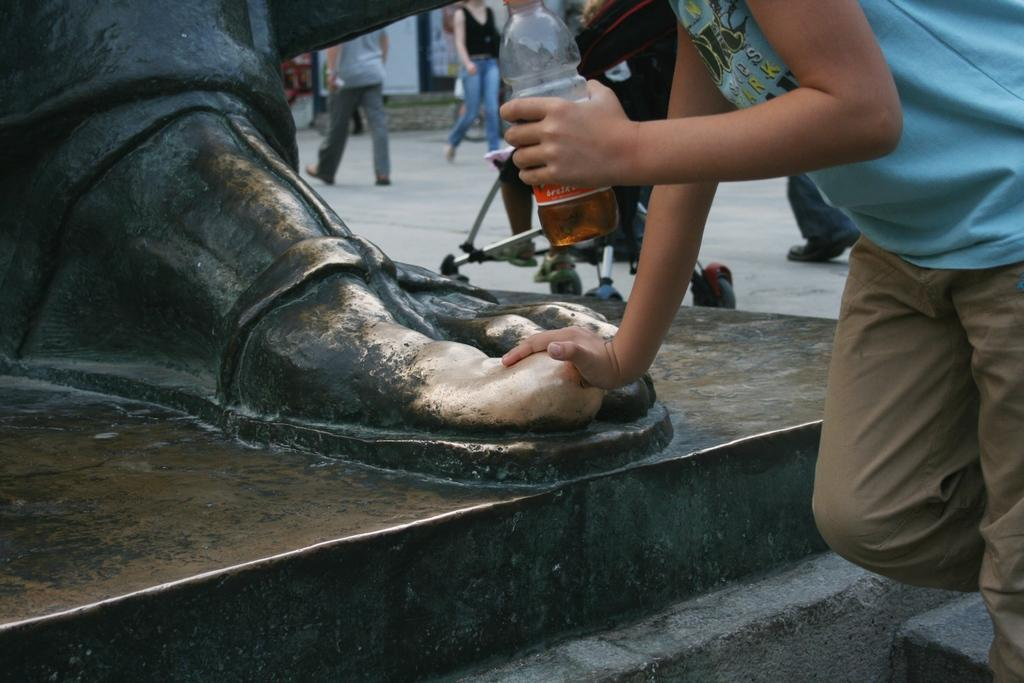What is the main subject of the image? There is a sculpture in the image. Are there any other elements in the image besides the sculpture? Yes, there is a group of people in the image. Can you describe the time of day when the image was taken? The image appears to be taken during the day. What is the setting of the image? The setting is on a road. What type of whip is being used by the sculpture in the image? There is no whip present in the image; it features a sculpture and a group of people on a road during the day. 